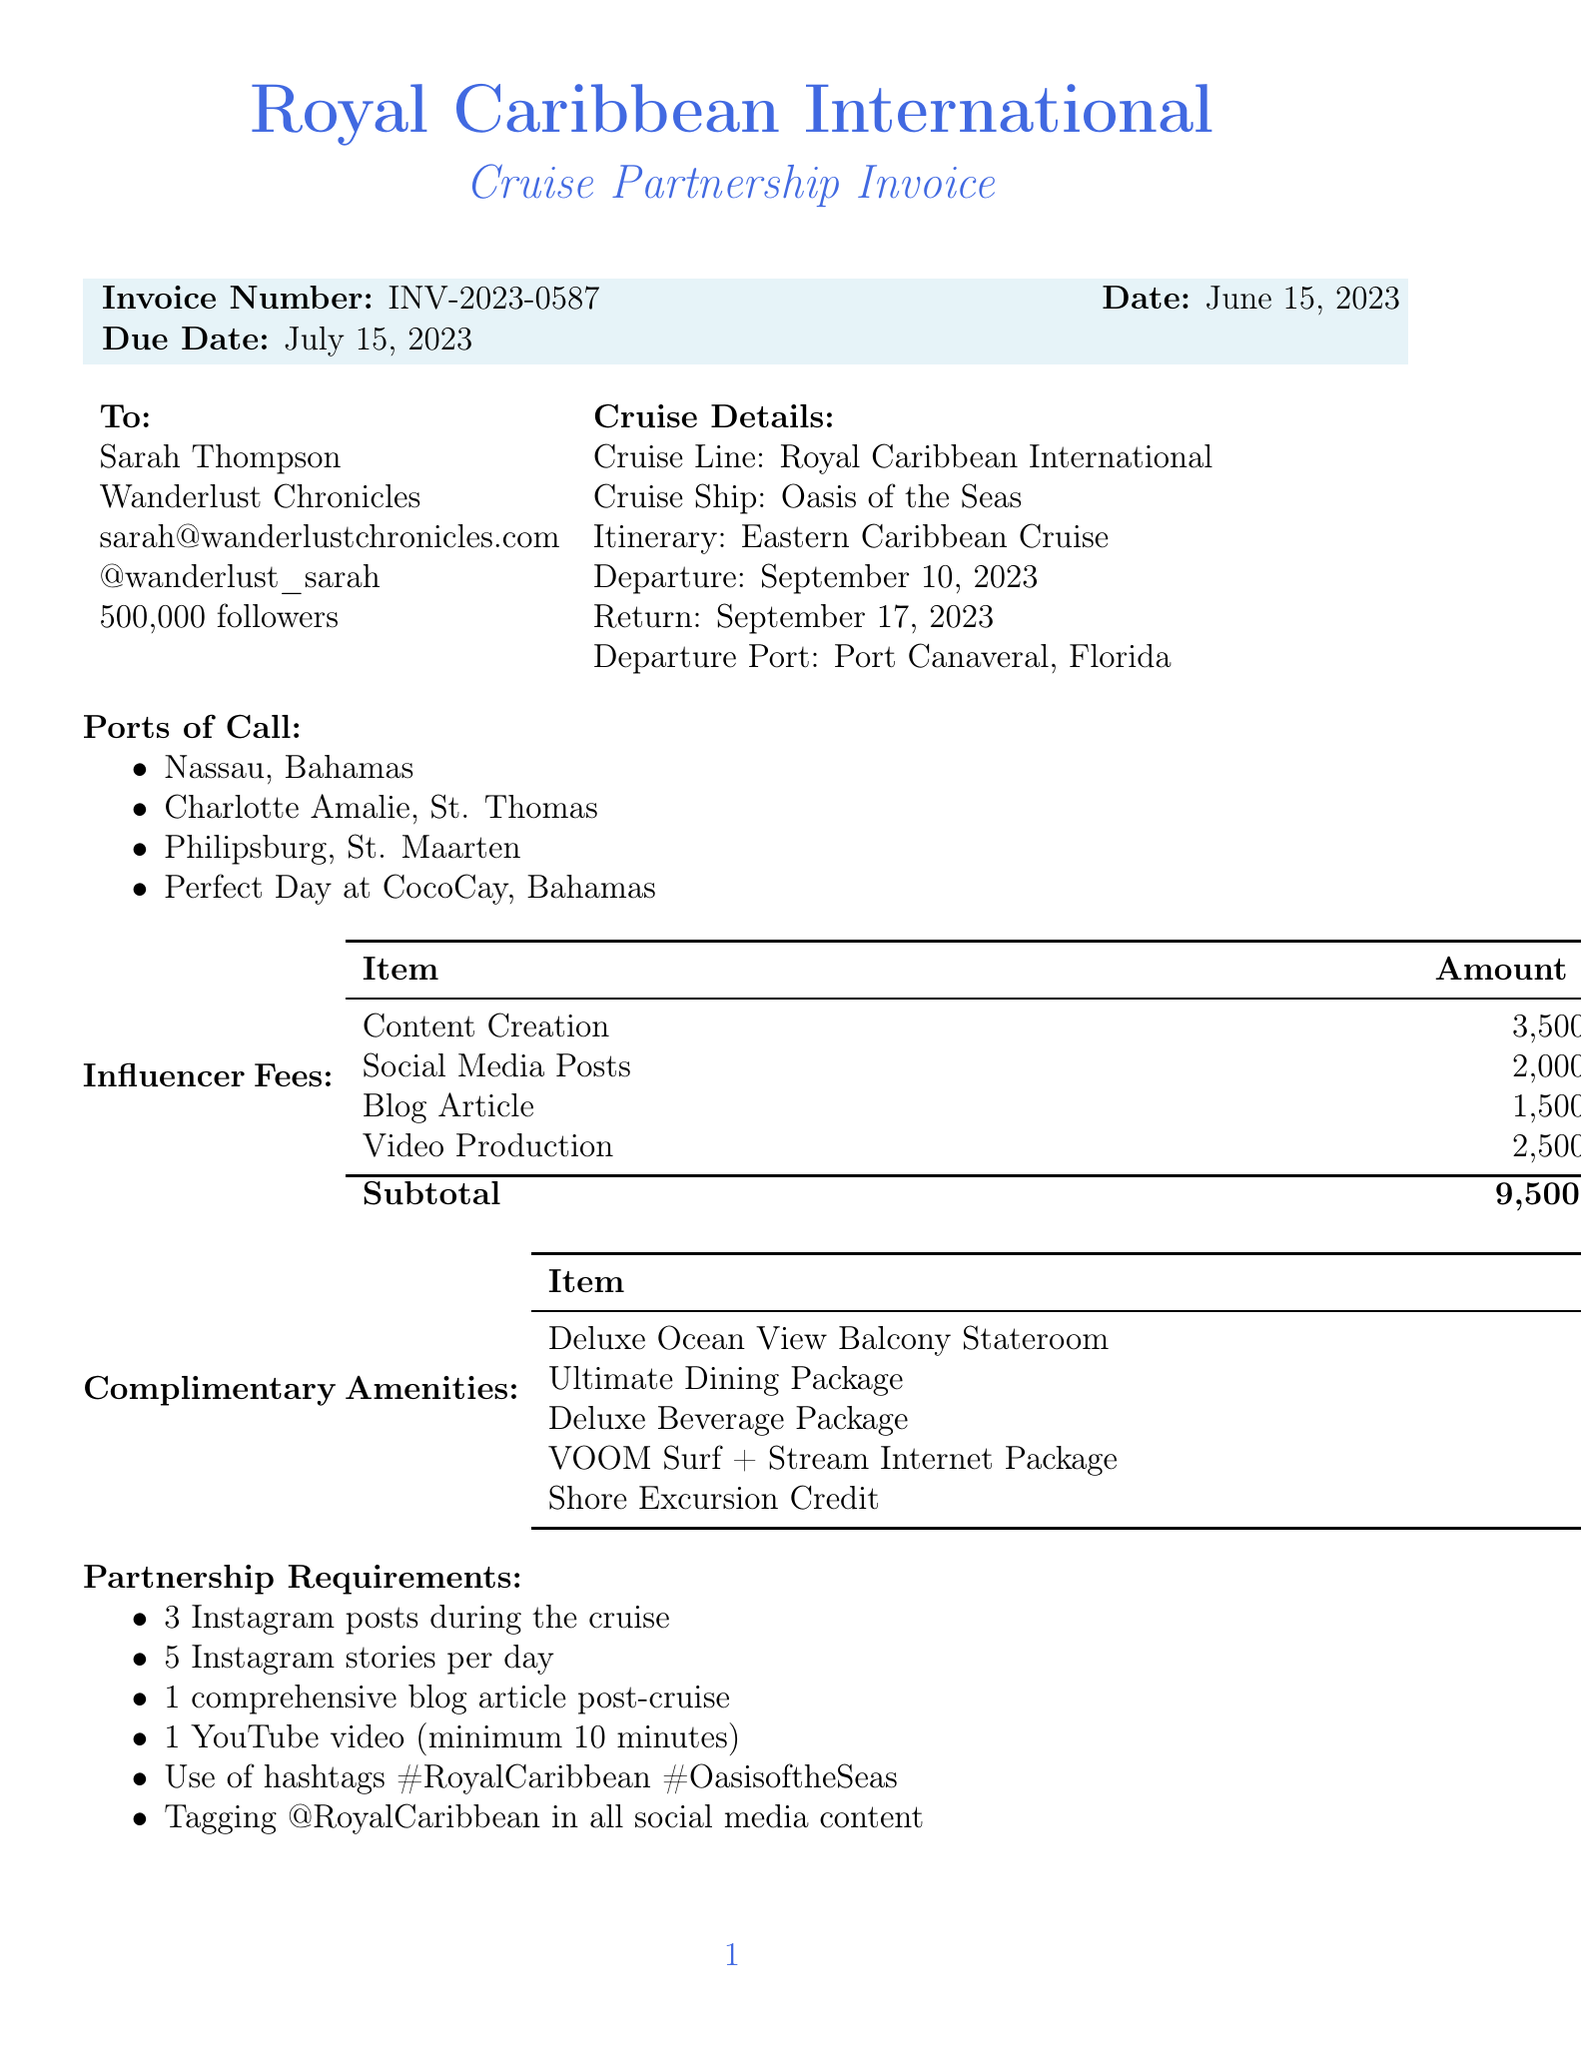What is the invoice number? The invoice number is specified in the document as INV-2023-0587.
Answer: INV-2023-0587 What is the due date for the invoice? The due date is clearly stated in the document as July 15, 2023.
Answer: July 15, 2023 What is the total due amount? The total due is calculated and mentioned as $10,260.00 in the payment details.
Answer: $10,260.00 How many Instagram posts are required during the cruise? The document states that 3 Instagram posts are required, found under partnership requirements.
Answer: 3 What is the value of the Deluxe Ocean View Balcony Stateroom? The document lists the value of this amenity as $2,799.00.
Answer: $2,799.00 What is the payment method mentioned in the document? The payment method is specified as bank transfer in the payment details section.
Answer: Bank transfer How many ports of call are listed in the cruise details? The document lists four ports of call under cruise details.
Answer: 4 What is the cancellation fee percentage stated in the terms and conditions? The terms state that a cancellation fee of 50% applies if cancelled within 30 days of departure.
Answer: 50% What is the name of the travel blogger? The travel blogger's name is explicitly mentioned as Sarah Thompson.
Answer: Sarah Thompson 